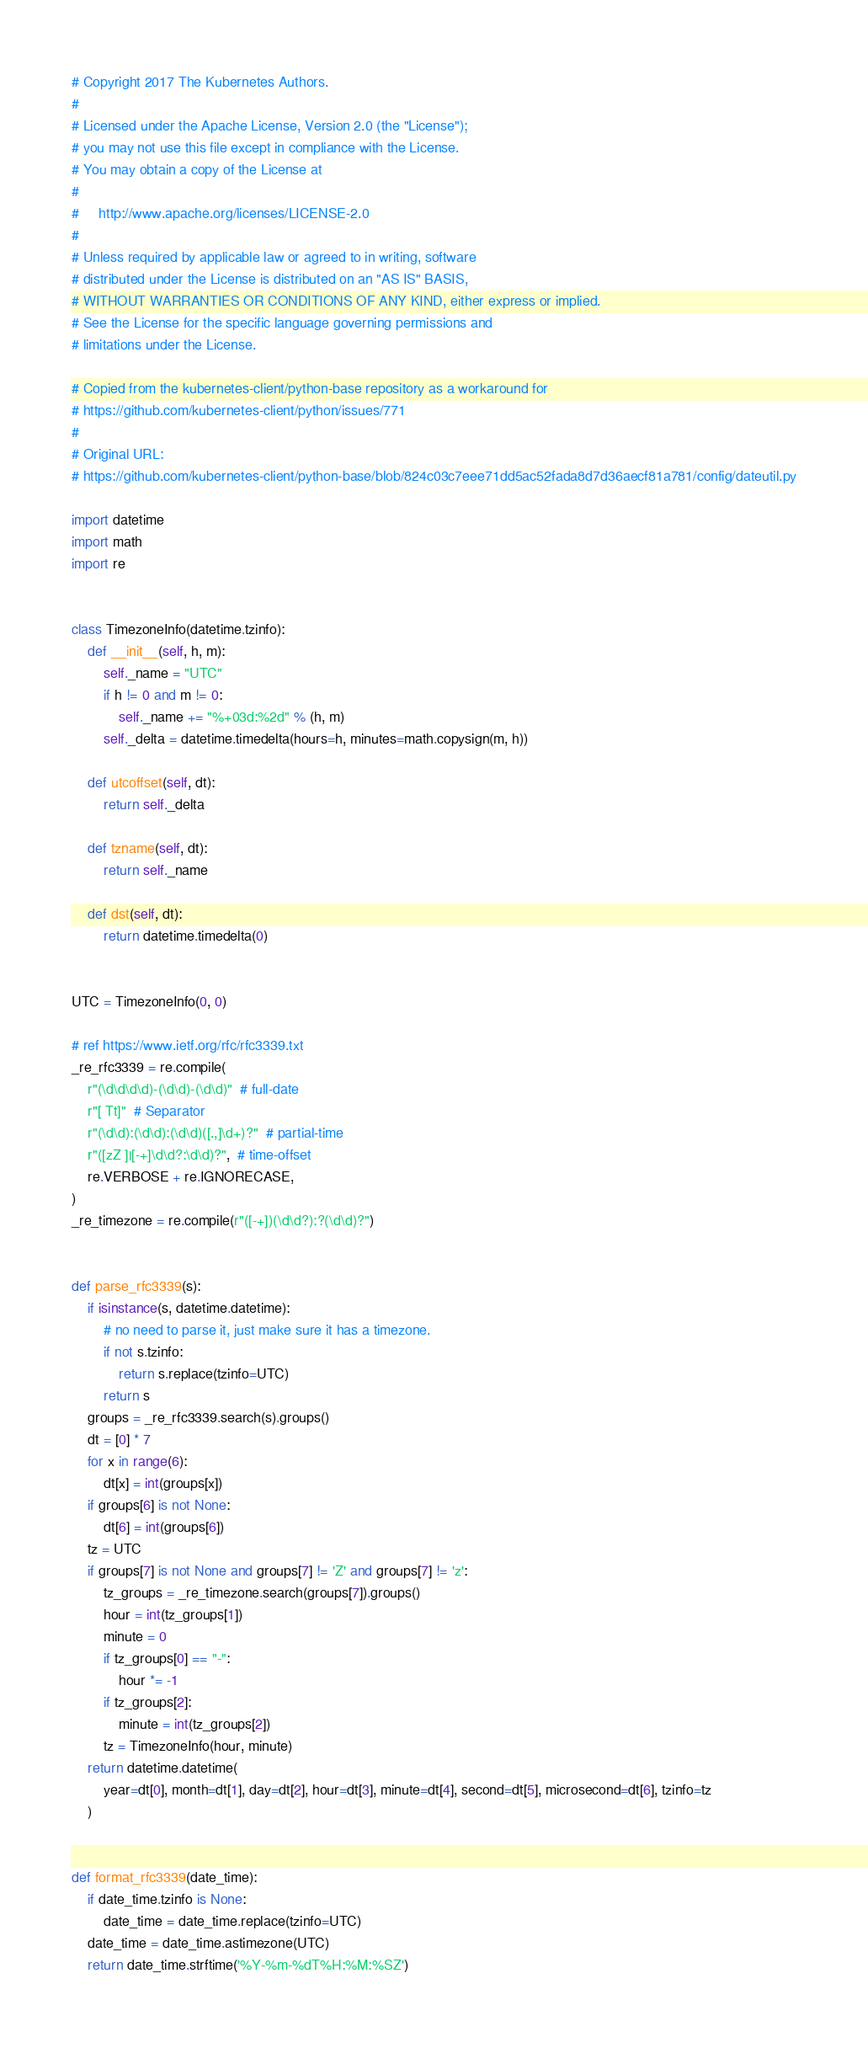Convert code to text. <code><loc_0><loc_0><loc_500><loc_500><_Python_># Copyright 2017 The Kubernetes Authors.
#
# Licensed under the Apache License, Version 2.0 (the "License");
# you may not use this file except in compliance with the License.
# You may obtain a copy of the License at
#
#     http://www.apache.org/licenses/LICENSE-2.0
#
# Unless required by applicable law or agreed to in writing, software
# distributed under the License is distributed on an "AS IS" BASIS,
# WITHOUT WARRANTIES OR CONDITIONS OF ANY KIND, either express or implied.
# See the License for the specific language governing permissions and
# limitations under the License.

# Copied from the kubernetes-client/python-base repository as a workaround for
# https://github.com/kubernetes-client/python/issues/771
#
# Original URL:
# https://github.com/kubernetes-client/python-base/blob/824c03c7eee71dd5ac52fada8d7d36aecf81a781/config/dateutil.py

import datetime
import math
import re


class TimezoneInfo(datetime.tzinfo):
    def __init__(self, h, m):
        self._name = "UTC"
        if h != 0 and m != 0:
            self._name += "%+03d:%2d" % (h, m)
        self._delta = datetime.timedelta(hours=h, minutes=math.copysign(m, h))

    def utcoffset(self, dt):
        return self._delta

    def tzname(self, dt):
        return self._name

    def dst(self, dt):
        return datetime.timedelta(0)


UTC = TimezoneInfo(0, 0)

# ref https://www.ietf.org/rfc/rfc3339.txt
_re_rfc3339 = re.compile(
    r"(\d\d\d\d)-(\d\d)-(\d\d)"  # full-date
    r"[ Tt]"  # Separator
    r"(\d\d):(\d\d):(\d\d)([.,]\d+)?"  # partial-time
    r"([zZ ]|[-+]\d\d?:\d\d)?",  # time-offset
    re.VERBOSE + re.IGNORECASE,
)
_re_timezone = re.compile(r"([-+])(\d\d?):?(\d\d)?")


def parse_rfc3339(s):
    if isinstance(s, datetime.datetime):
        # no need to parse it, just make sure it has a timezone.
        if not s.tzinfo:
            return s.replace(tzinfo=UTC)
        return s
    groups = _re_rfc3339.search(s).groups()
    dt = [0] * 7
    for x in range(6):
        dt[x] = int(groups[x])
    if groups[6] is not None:
        dt[6] = int(groups[6])
    tz = UTC
    if groups[7] is not None and groups[7] != 'Z' and groups[7] != 'z':
        tz_groups = _re_timezone.search(groups[7]).groups()
        hour = int(tz_groups[1])
        minute = 0
        if tz_groups[0] == "-":
            hour *= -1
        if tz_groups[2]:
            minute = int(tz_groups[2])
        tz = TimezoneInfo(hour, minute)
    return datetime.datetime(
        year=dt[0], month=dt[1], day=dt[2], hour=dt[3], minute=dt[4], second=dt[5], microsecond=dt[6], tzinfo=tz
    )


def format_rfc3339(date_time):
    if date_time.tzinfo is None:
        date_time = date_time.replace(tzinfo=UTC)
    date_time = date_time.astimezone(UTC)
    return date_time.strftime('%Y-%m-%dT%H:%M:%SZ')
</code> 